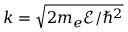Convert formula to latex. <formula><loc_0><loc_0><loc_500><loc_500>k = \sqrt { 2 m _ { e } \mathcal { E } / \hbar { ^ } { 2 } }</formula> 